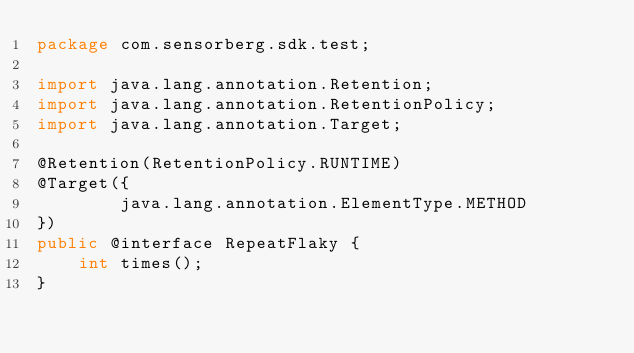Convert code to text. <code><loc_0><loc_0><loc_500><loc_500><_Java_>package com.sensorberg.sdk.test;

import java.lang.annotation.Retention;
import java.lang.annotation.RetentionPolicy;
import java.lang.annotation.Target;

@Retention(RetentionPolicy.RUNTIME)
@Target({
        java.lang.annotation.ElementType.METHOD
})
public @interface RepeatFlaky {
    int times();
}
</code> 